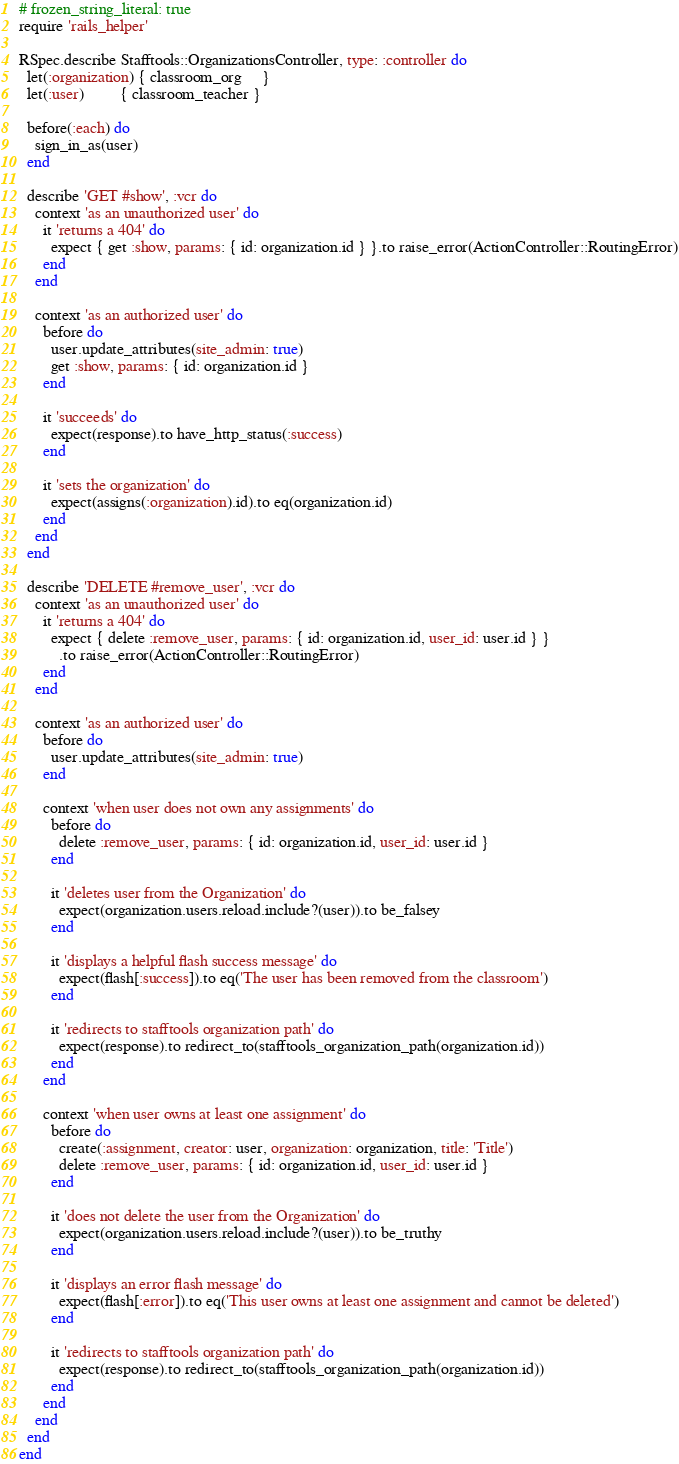<code> <loc_0><loc_0><loc_500><loc_500><_Ruby_># frozen_string_literal: true
require 'rails_helper'

RSpec.describe Stafftools::OrganizationsController, type: :controller do
  let(:organization) { classroom_org     }
  let(:user)         { classroom_teacher }

  before(:each) do
    sign_in_as(user)
  end

  describe 'GET #show', :vcr do
    context 'as an unauthorized user' do
      it 'returns a 404' do
        expect { get :show, params: { id: organization.id } }.to raise_error(ActionController::RoutingError)
      end
    end

    context 'as an authorized user' do
      before do
        user.update_attributes(site_admin: true)
        get :show, params: { id: organization.id }
      end

      it 'succeeds' do
        expect(response).to have_http_status(:success)
      end

      it 'sets the organization' do
        expect(assigns(:organization).id).to eq(organization.id)
      end
    end
  end

  describe 'DELETE #remove_user', :vcr do
    context 'as an unauthorized user' do
      it 'returns a 404' do
        expect { delete :remove_user, params: { id: organization.id, user_id: user.id } }
          .to raise_error(ActionController::RoutingError)
      end
    end

    context 'as an authorized user' do
      before do
        user.update_attributes(site_admin: true)
      end

      context 'when user does not own any assignments' do
        before do
          delete :remove_user, params: { id: organization.id, user_id: user.id }
        end

        it 'deletes user from the Organization' do
          expect(organization.users.reload.include?(user)).to be_falsey
        end

        it 'displays a helpful flash success message' do
          expect(flash[:success]).to eq('The user has been removed from the classroom')
        end

        it 'redirects to stafftools organization path' do
          expect(response).to redirect_to(stafftools_organization_path(organization.id))
        end
      end

      context 'when user owns at least one assignment' do
        before do
          create(:assignment, creator: user, organization: organization, title: 'Title')
          delete :remove_user, params: { id: organization.id, user_id: user.id }
        end

        it 'does not delete the user from the Organization' do
          expect(organization.users.reload.include?(user)).to be_truthy
        end

        it 'displays an error flash message' do
          expect(flash[:error]).to eq('This user owns at least one assignment and cannot be deleted')
        end

        it 'redirects to stafftools organization path' do
          expect(response).to redirect_to(stafftools_organization_path(organization.id))
        end
      end
    end
  end
end
</code> 